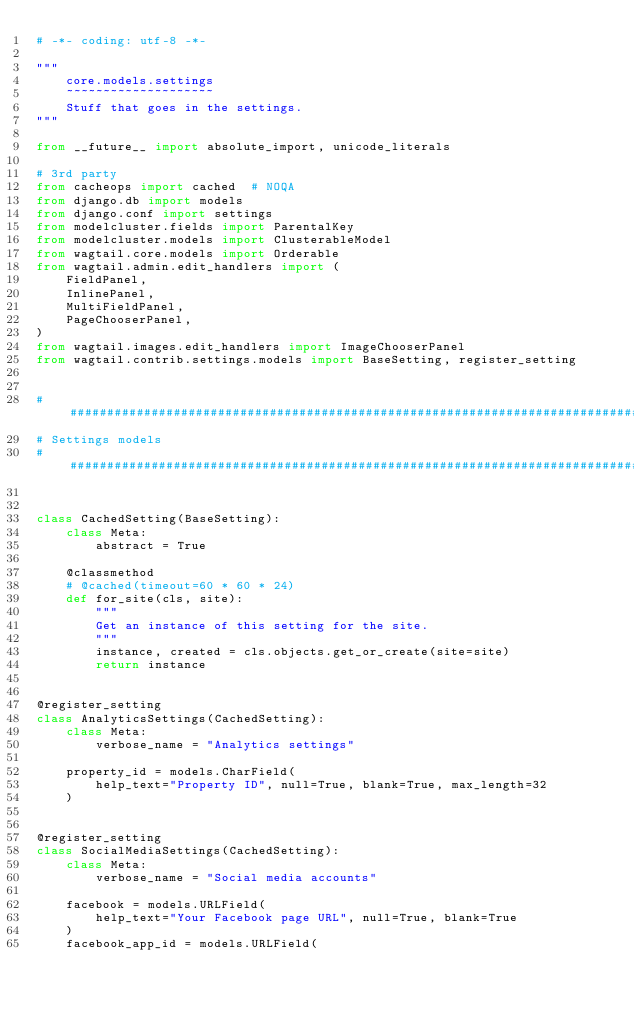Convert code to text. <code><loc_0><loc_0><loc_500><loc_500><_Python_># -*- coding: utf-8 -*-

"""
    core.models.settings
    ~~~~~~~~~~~~~~~~~~~~
    Stuff that goes in the settings.
"""

from __future__ import absolute_import, unicode_literals

# 3rd party
from cacheops import cached  # NOQA
from django.db import models
from django.conf import settings
from modelcluster.fields import ParentalKey
from modelcluster.models import ClusterableModel
from wagtail.core.models import Orderable
from wagtail.admin.edit_handlers import (
    FieldPanel,
    InlinePanel,
    MultiFieldPanel,
    PageChooserPanel,
)
from wagtail.images.edit_handlers import ImageChooserPanel
from wagtail.contrib.settings.models import BaseSetting, register_setting


################################################################################
# Settings models
################################################################################


class CachedSetting(BaseSetting):
    class Meta:
        abstract = True

    @classmethod
    # @cached(timeout=60 * 60 * 24)
    def for_site(cls, site):
        """
        Get an instance of this setting for the site.
        """
        instance, created = cls.objects.get_or_create(site=site)
        return instance


@register_setting
class AnalyticsSettings(CachedSetting):
    class Meta:
        verbose_name = "Analytics settings"

    property_id = models.CharField(
        help_text="Property ID", null=True, blank=True, max_length=32
    )


@register_setting
class SocialMediaSettings(CachedSetting):
    class Meta:
        verbose_name = "Social media accounts"

    facebook = models.URLField(
        help_text="Your Facebook page URL", null=True, blank=True
    )
    facebook_app_id = models.URLField(</code> 